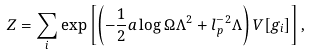<formula> <loc_0><loc_0><loc_500><loc_500>Z = \sum _ { i } \exp \left [ \left ( - \frac { 1 } { 2 } a \log \Omega \Lambda ^ { 2 } + l _ { p } ^ { - 2 } \Lambda \right ) V [ g _ { i } ] \right ] ,</formula> 